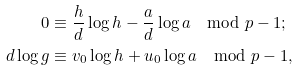Convert formula to latex. <formula><loc_0><loc_0><loc_500><loc_500>0 & \equiv \frac { h } { d } \log h - \frac { a } { d } \log a \mod { p - 1 } ; \\ d \log g & \equiv v _ { 0 } \log h + u _ { 0 } \log a \mod { p - 1 } ,</formula> 